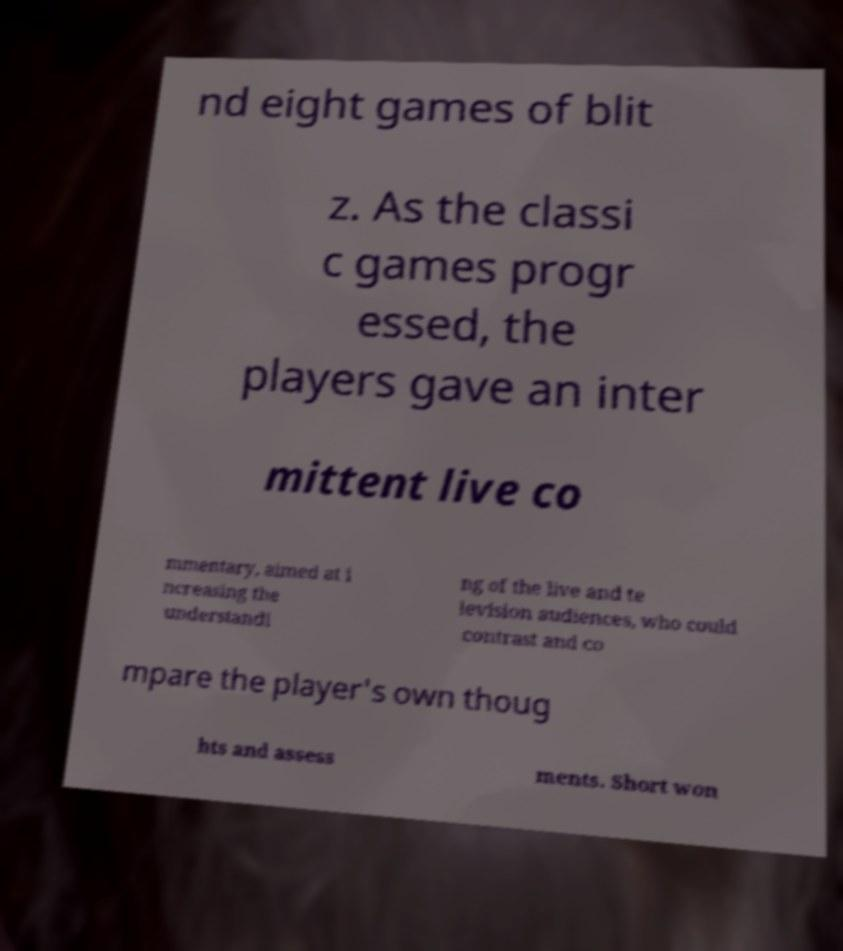For documentation purposes, I need the text within this image transcribed. Could you provide that? nd eight games of blit z. As the classi c games progr essed, the players gave an inter mittent live co mmentary, aimed at i ncreasing the understandi ng of the live and te levision audiences, who could contrast and co mpare the player's own thoug hts and assess ments. Short won 